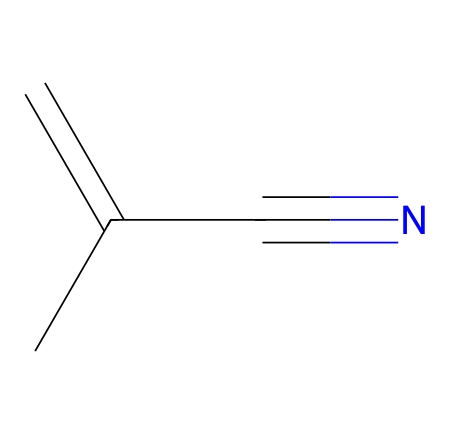How many carbon atoms are in methacrylonitrile? The chemical structure shows three carbon atoms connected in a chain, along with a branched carbon. Thus, the total count of carbon atoms is three.
Answer: three What functional group is present in methacrylonitrile? The presence of a carbon triple-bonded to a nitrogen atom (C#N) indicates that the functional group in this chemical is a nitrile group.
Answer: nitrile What type of bond connects the carbon and nitrogen in methacrylonitrile? The notation C#N in the SMILES representation indicates a triple bond between the carbon and nitrogen atoms, which is characteristic of nitriles.
Answer: triple bond How many double bonds are present in methacrylonitrile? Analyzing the SMILES notation, the presence of "C=C" shows that there is one double bond in the structure between the two carbon atoms.
Answer: one What is the saturated/unsaturated nature of methacrylonitrile? The presence of a carbon-carbon double bond indicates that the compound is unsaturated, as saturated compounds have single bonds only.
Answer: unsaturated Does methacrylonitrile undergo polymerization? Yes, the presence of a double bond allows methacrylonitrile to easily undergo polymerization, forming longer chains or polymers commonly used in plastics.
Answer: yes 